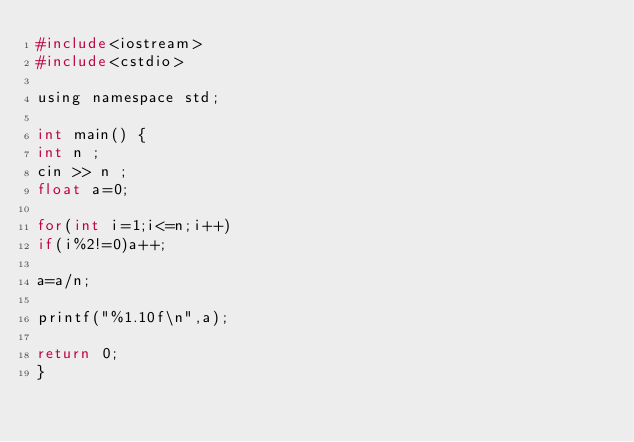Convert code to text. <code><loc_0><loc_0><loc_500><loc_500><_C_>#include<iostream>
#include<cstdio>

using namespace std;

int main() {
int n ;
cin >> n ;
float a=0;

for(int i=1;i<=n;i++)
if(i%2!=0)a++;

a=a/n;

printf("%1.10f\n",a);

return 0;
}
</code> 